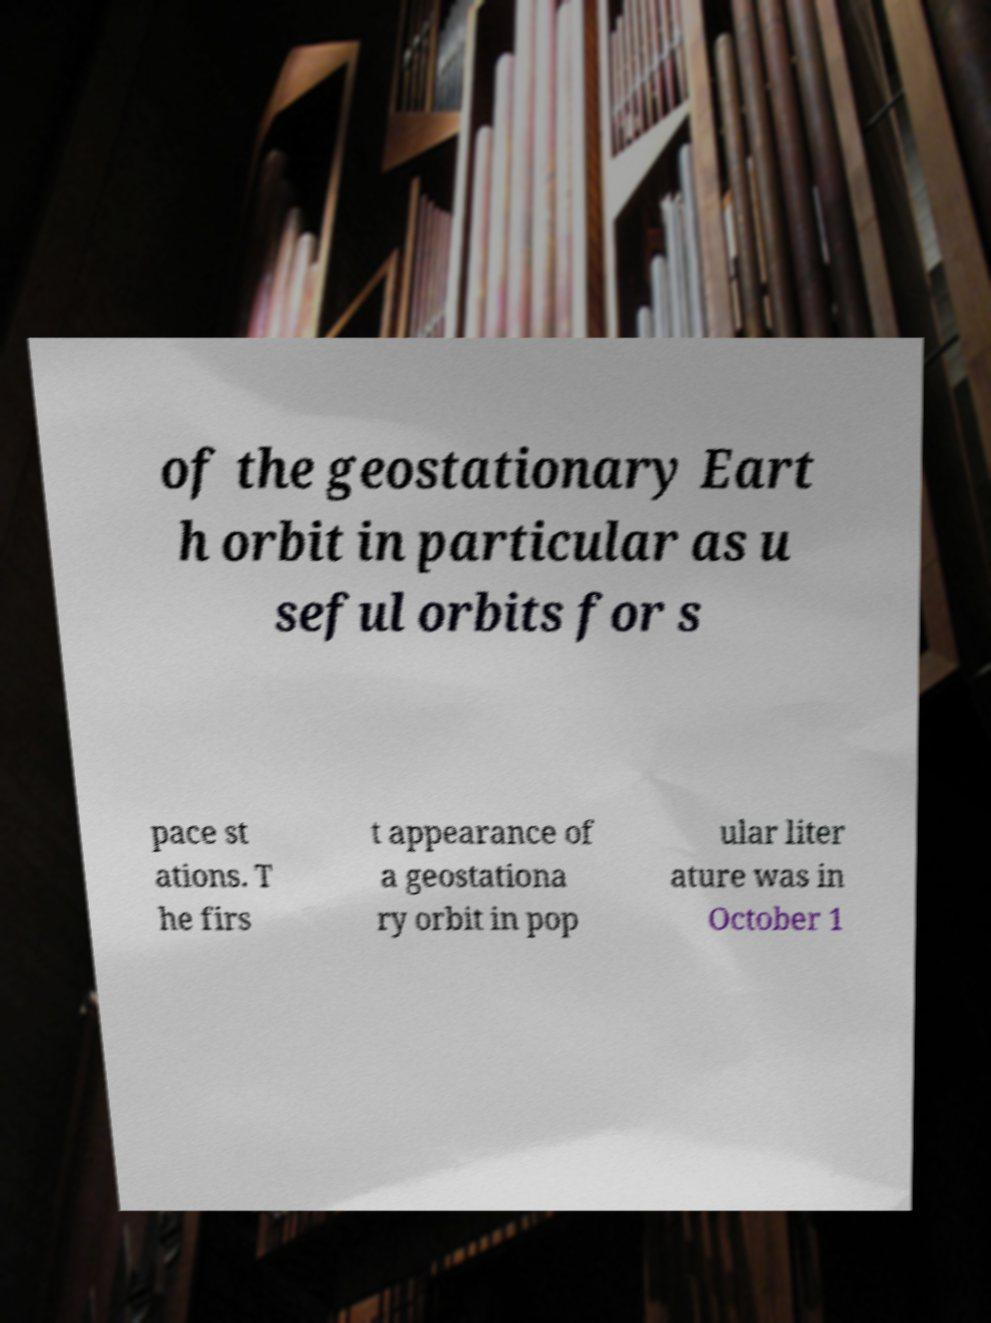I need the written content from this picture converted into text. Can you do that? of the geostationary Eart h orbit in particular as u seful orbits for s pace st ations. T he firs t appearance of a geostationa ry orbit in pop ular liter ature was in October 1 